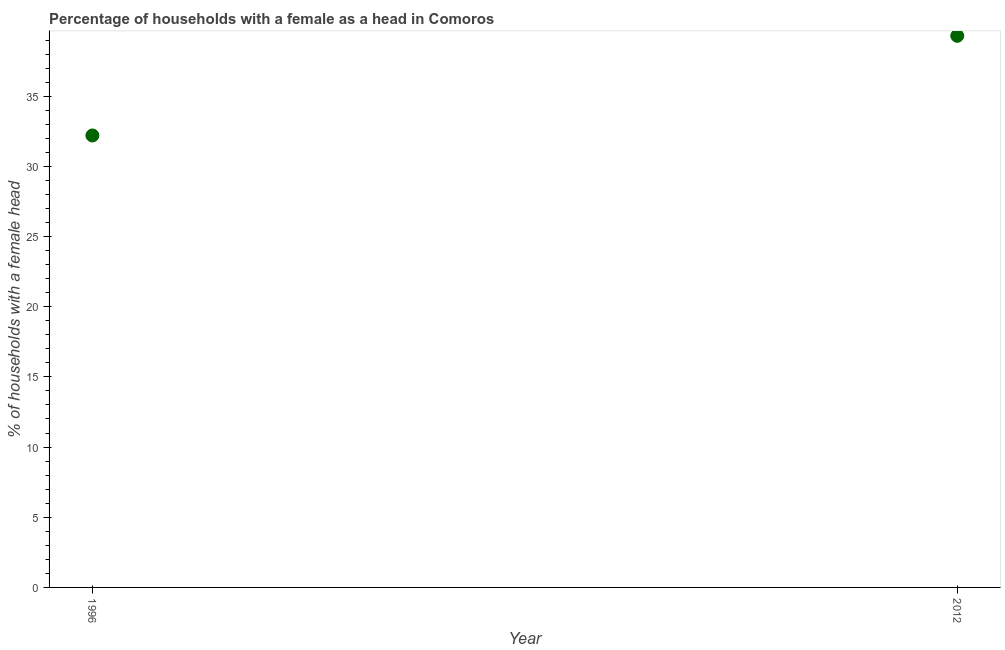What is the number of female supervised households in 1996?
Provide a succinct answer. 32.2. Across all years, what is the maximum number of female supervised households?
Provide a short and direct response. 39.3. Across all years, what is the minimum number of female supervised households?
Your answer should be very brief. 32.2. What is the sum of the number of female supervised households?
Give a very brief answer. 71.5. What is the difference between the number of female supervised households in 1996 and 2012?
Give a very brief answer. -7.1. What is the average number of female supervised households per year?
Offer a very short reply. 35.75. What is the median number of female supervised households?
Your answer should be very brief. 35.75. In how many years, is the number of female supervised households greater than 30 %?
Offer a terse response. 2. Do a majority of the years between 2012 and 1996 (inclusive) have number of female supervised households greater than 31 %?
Your response must be concise. No. What is the ratio of the number of female supervised households in 1996 to that in 2012?
Provide a short and direct response. 0.82. In how many years, is the number of female supervised households greater than the average number of female supervised households taken over all years?
Your response must be concise. 1. Does the number of female supervised households monotonically increase over the years?
Make the answer very short. Yes. How many dotlines are there?
Give a very brief answer. 1. What is the difference between two consecutive major ticks on the Y-axis?
Make the answer very short. 5. Are the values on the major ticks of Y-axis written in scientific E-notation?
Ensure brevity in your answer.  No. Does the graph contain grids?
Offer a terse response. No. What is the title of the graph?
Provide a succinct answer. Percentage of households with a female as a head in Comoros. What is the label or title of the Y-axis?
Offer a terse response. % of households with a female head. What is the % of households with a female head in 1996?
Ensure brevity in your answer.  32.2. What is the % of households with a female head in 2012?
Provide a short and direct response. 39.3. What is the difference between the % of households with a female head in 1996 and 2012?
Offer a very short reply. -7.1. What is the ratio of the % of households with a female head in 1996 to that in 2012?
Make the answer very short. 0.82. 